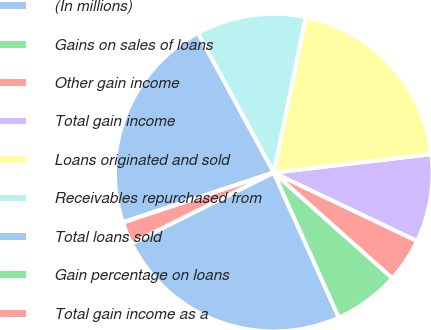Convert chart. <chart><loc_0><loc_0><loc_500><loc_500><pie_chart><fcel>(In millions)<fcel>Gains on sales of loans<fcel>Other gain income<fcel>Total gain income<fcel>Loans originated and sold<fcel>Receivables repurchased from<fcel>Total loans sold<fcel>Gain percentage on loans<fcel>Total gain income as a<nl><fcel>24.36%<fcel>6.71%<fcel>4.49%<fcel>8.94%<fcel>19.91%<fcel>11.16%<fcel>22.13%<fcel>0.04%<fcel>2.26%<nl></chart> 